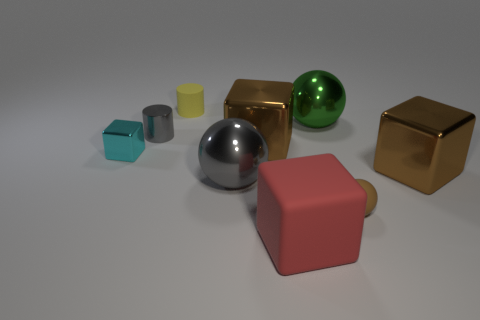There is another sphere that is the same size as the green shiny ball; what material is it?
Offer a very short reply. Metal. Is there a green sphere that has the same material as the small brown thing?
Your response must be concise. No. Do the small yellow object and the brown object to the left of the tiny ball have the same shape?
Keep it short and to the point. No. How many big things are both behind the cyan metallic object and in front of the large gray metal object?
Offer a very short reply. 0. Do the cyan object and the big ball that is left of the red object have the same material?
Your answer should be compact. Yes. Are there an equal number of tiny matte objects that are right of the green ball and small cyan objects?
Provide a short and direct response. Yes. There is a cylinder left of the rubber cylinder; what color is it?
Offer a very short reply. Gray. What number of other things are the same color as the rubber cylinder?
Keep it short and to the point. 0. Is there anything else that is the same size as the cyan block?
Your response must be concise. Yes. There is a object that is right of the brown ball; is its size the same as the green object?
Make the answer very short. Yes. 